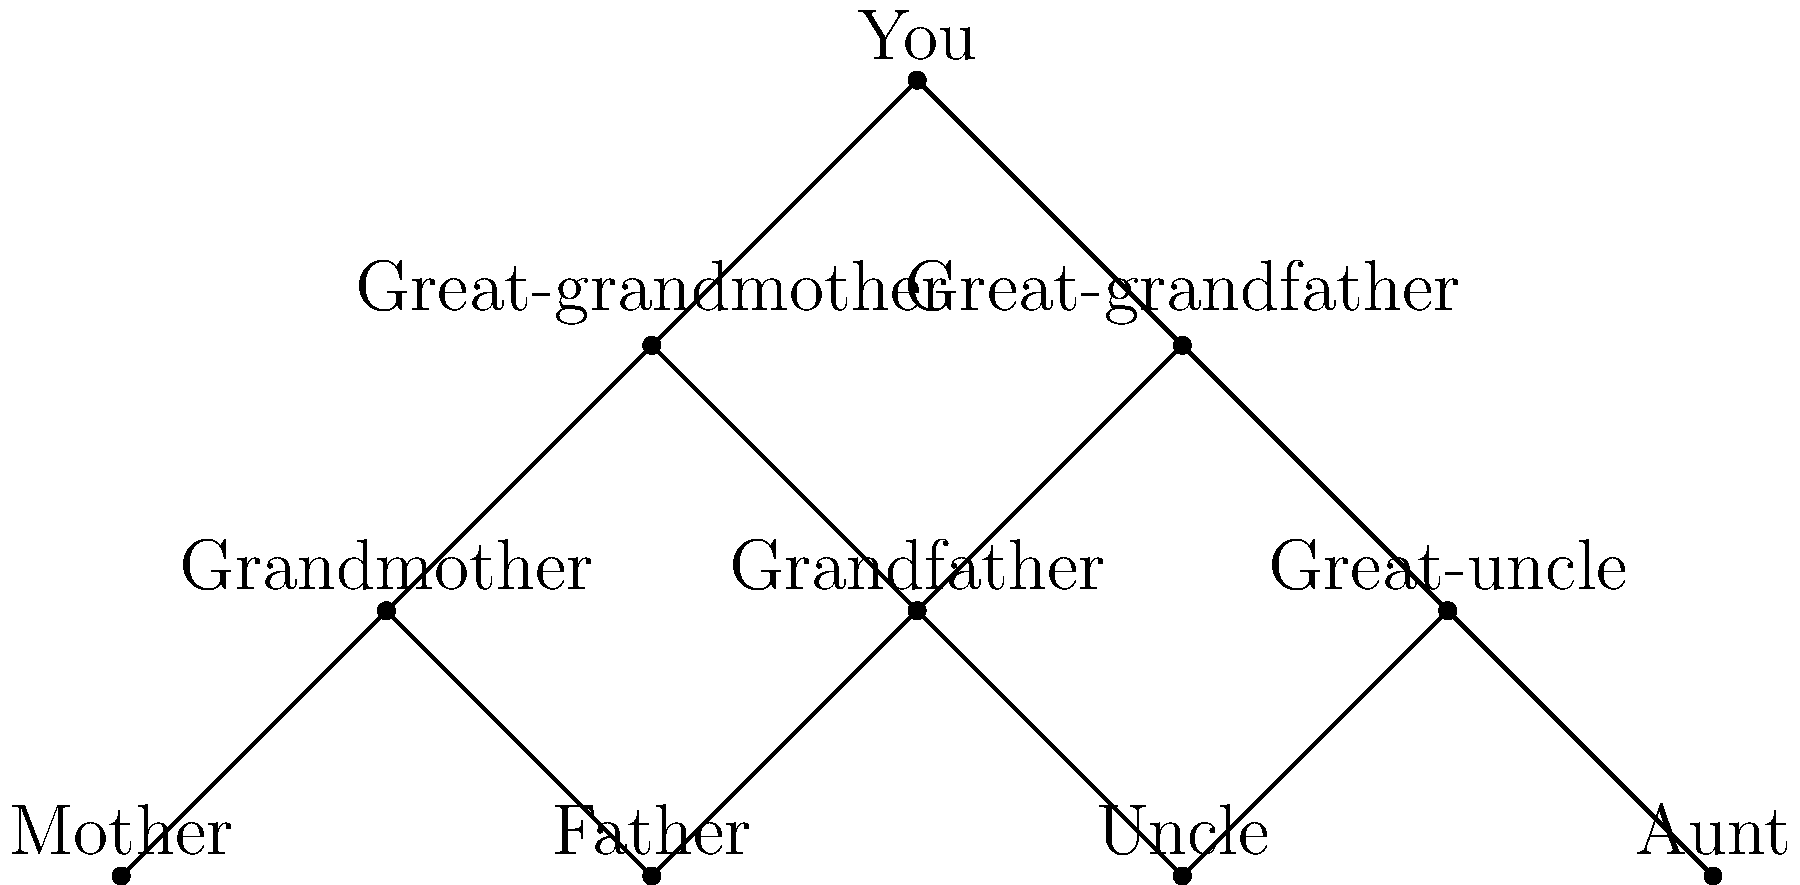Based on the family tree diagram, which individual is most likely to be the famous seafarer ancestor you're tracing your lineage to? To determine the most likely famous seafarer ancestor, we need to consider the following steps:

1. The question states that we're tracing ancestry back to a famous seafarer, implying this person would be in an earlier generation.

2. The earliest generation shown in the family tree is the great-grandparent level.

3. There are two individuals at the great-grandparent level: the great-grandfather and great-grandmother.

4. Historically, seafaring was predominantly a male occupation, especially for famous seafarers from earlier periods.

5. Given this historical context, the great-grandfather is more likely to be the famous seafarer ancestor than the great-grandmother.

6. While it's possible that the seafarer could be from an even earlier generation not shown in this diagram, among the individuals presented, the great-grandfather is the most probable candidate.

Therefore, based on the information provided in the family tree and historical context, the great-grandfather is the most likely individual to be the famous seafarer ancestor.
Answer: Great-grandfather 